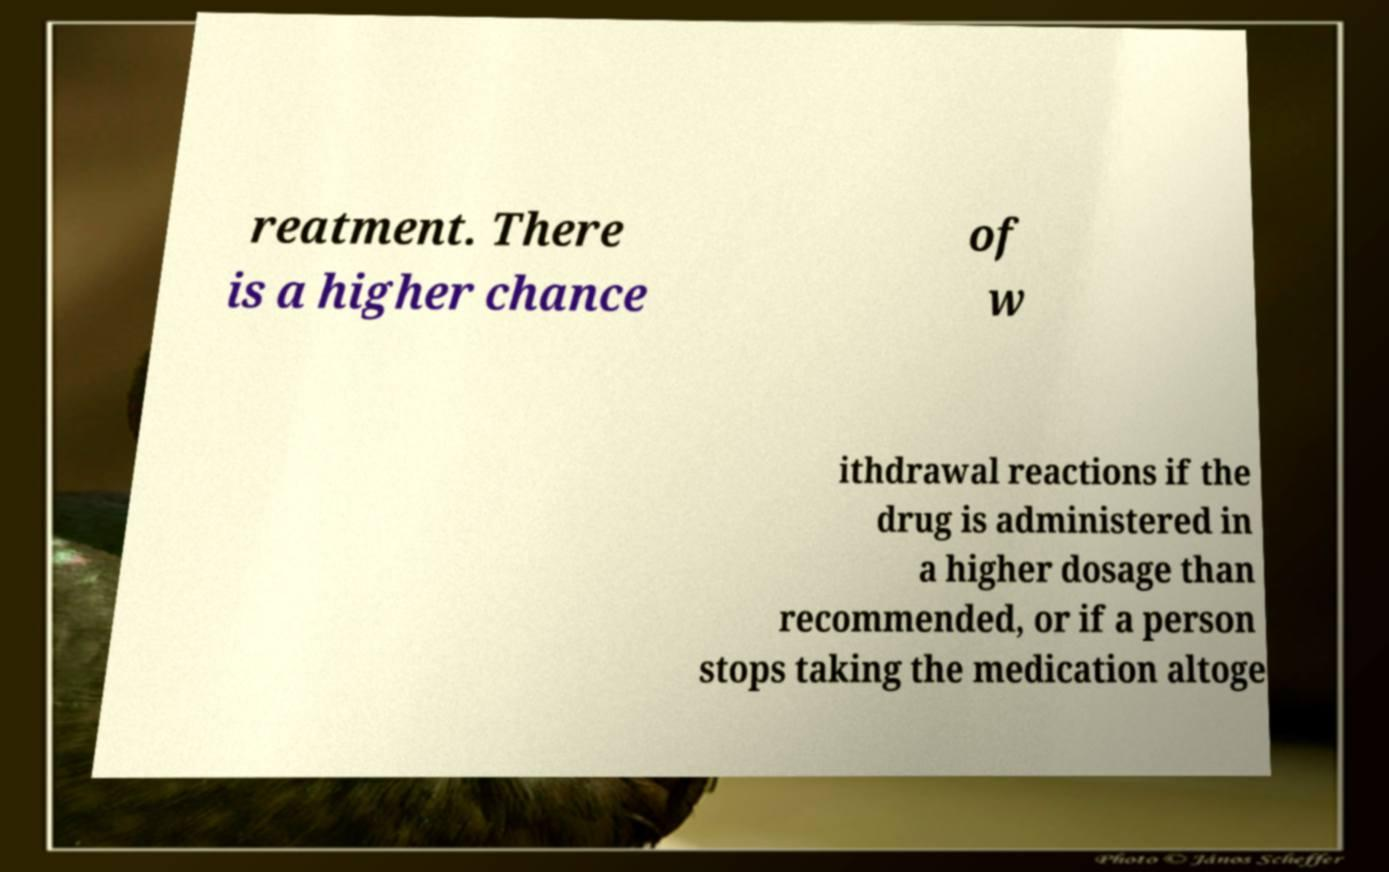Can you accurately transcribe the text from the provided image for me? reatment. There is a higher chance of w ithdrawal reactions if the drug is administered in a higher dosage than recommended, or if a person stops taking the medication altoge 